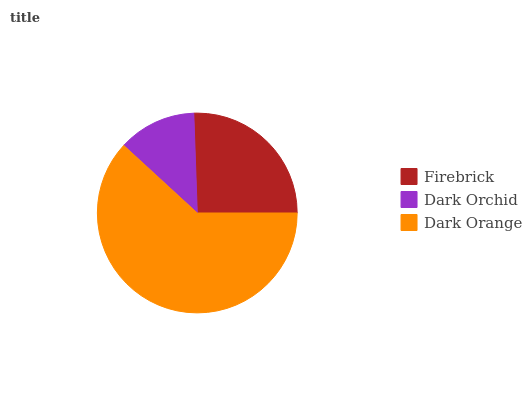Is Dark Orchid the minimum?
Answer yes or no. Yes. Is Dark Orange the maximum?
Answer yes or no. Yes. Is Dark Orange the minimum?
Answer yes or no. No. Is Dark Orchid the maximum?
Answer yes or no. No. Is Dark Orange greater than Dark Orchid?
Answer yes or no. Yes. Is Dark Orchid less than Dark Orange?
Answer yes or no. Yes. Is Dark Orchid greater than Dark Orange?
Answer yes or no. No. Is Dark Orange less than Dark Orchid?
Answer yes or no. No. Is Firebrick the high median?
Answer yes or no. Yes. Is Firebrick the low median?
Answer yes or no. Yes. Is Dark Orchid the high median?
Answer yes or no. No. Is Dark Orchid the low median?
Answer yes or no. No. 